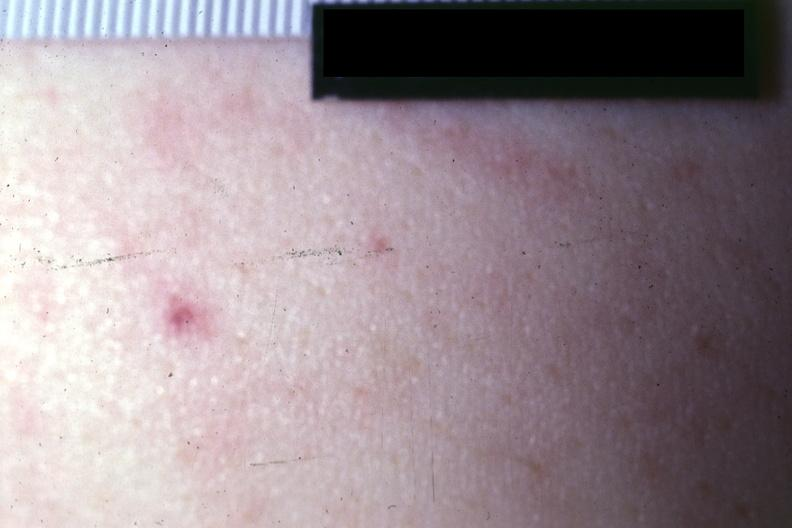does this image show close-up photo quite good?
Answer the question using a single word or phrase. Yes 